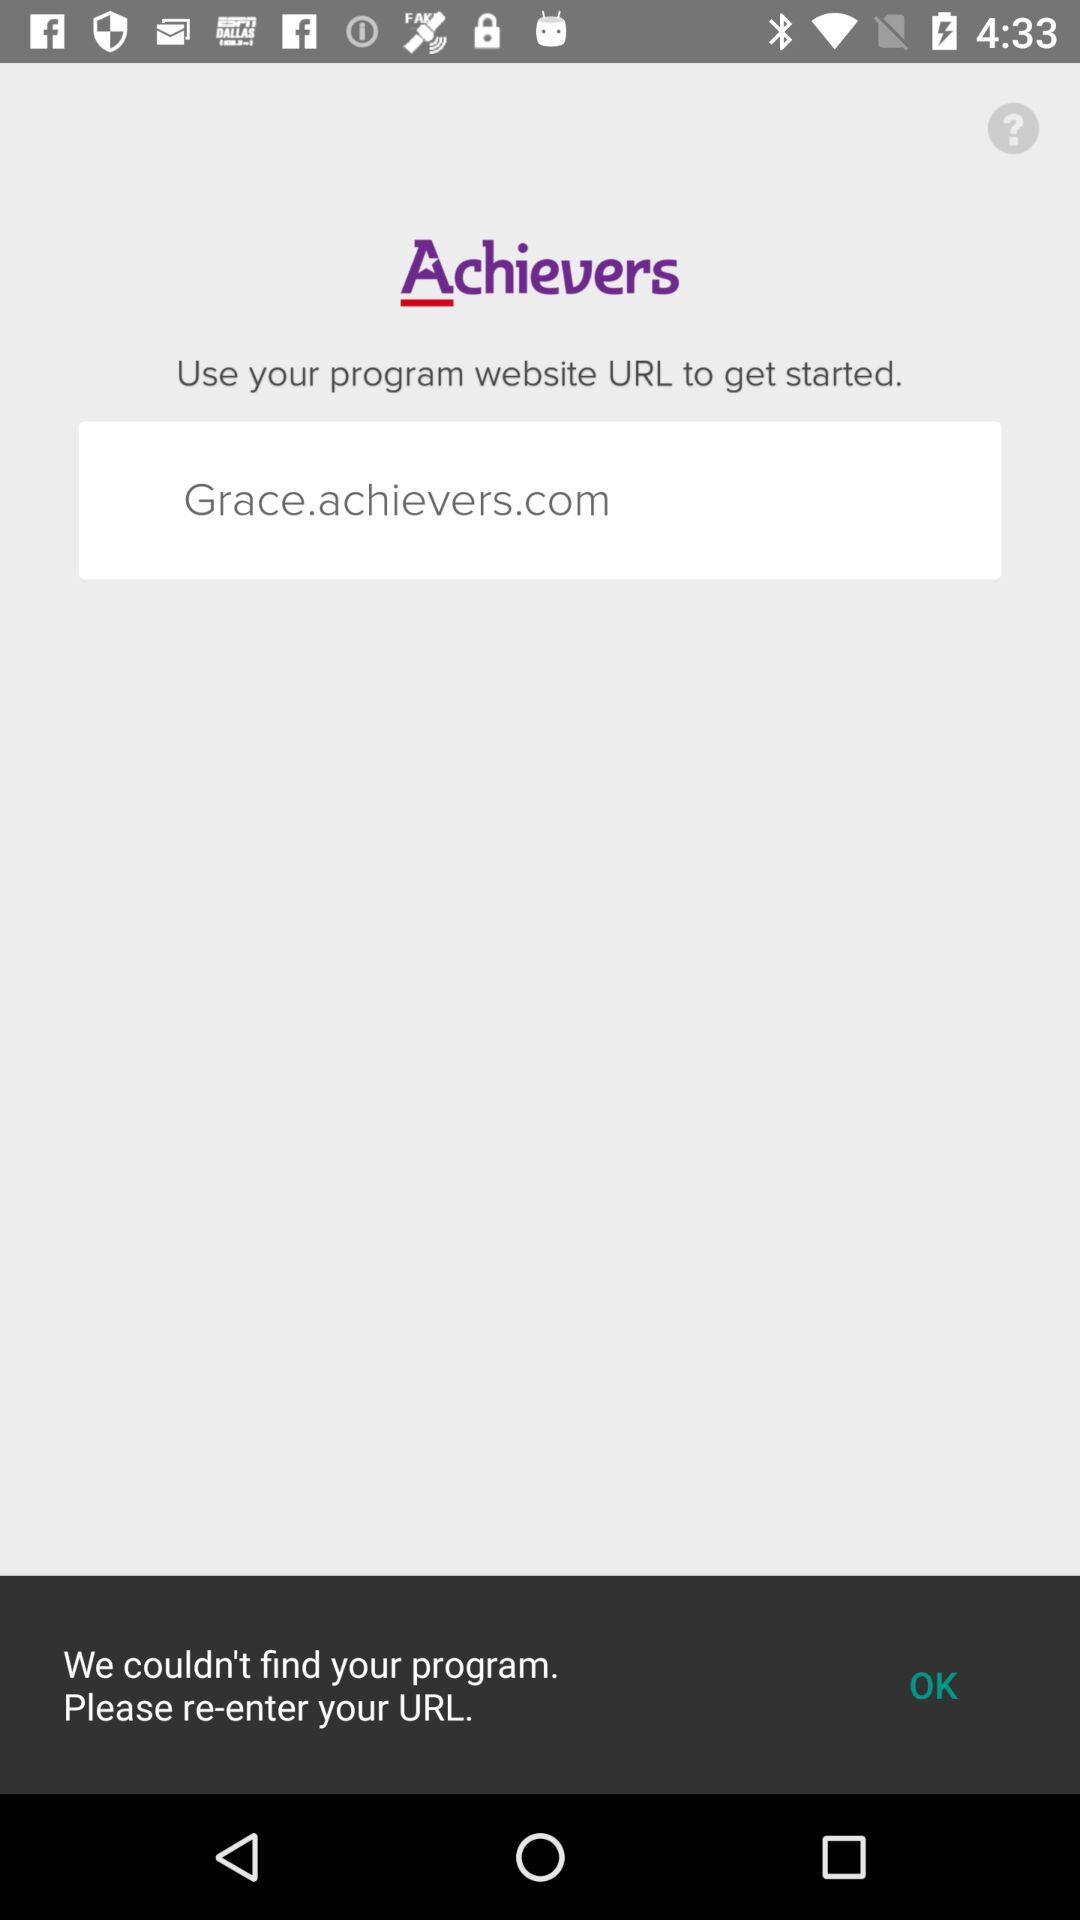What is the application name? The application name is "Achievers". 